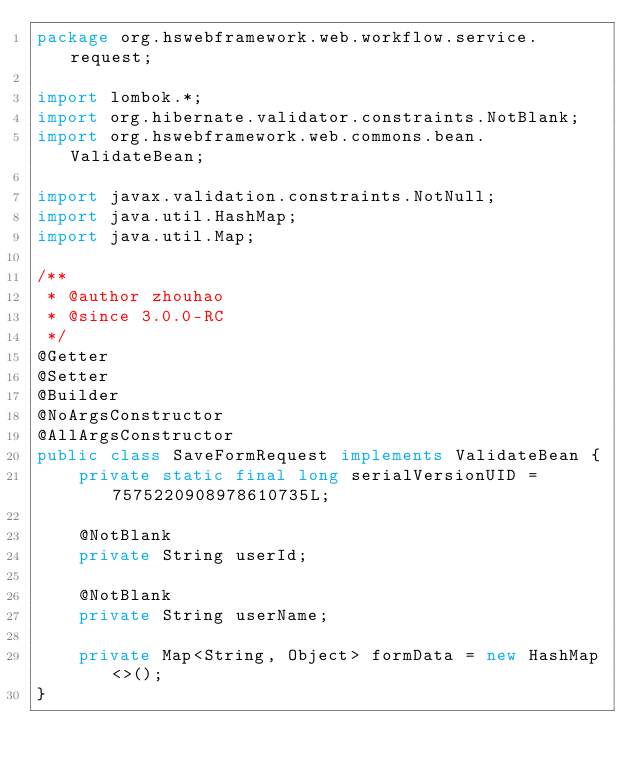<code> <loc_0><loc_0><loc_500><loc_500><_Java_>package org.hswebframework.web.workflow.service.request;

import lombok.*;
import org.hibernate.validator.constraints.NotBlank;
import org.hswebframework.web.commons.bean.ValidateBean;

import javax.validation.constraints.NotNull;
import java.util.HashMap;
import java.util.Map;

/**
 * @author zhouhao
 * @since 3.0.0-RC
 */
@Getter
@Setter
@Builder
@NoArgsConstructor
@AllArgsConstructor
public class SaveFormRequest implements ValidateBean {
    private static final long serialVersionUID = 7575220908978610735L;

    @NotBlank
    private String userId;

    @NotBlank
    private String userName;

    private Map<String, Object> formData = new HashMap<>();
}
</code> 